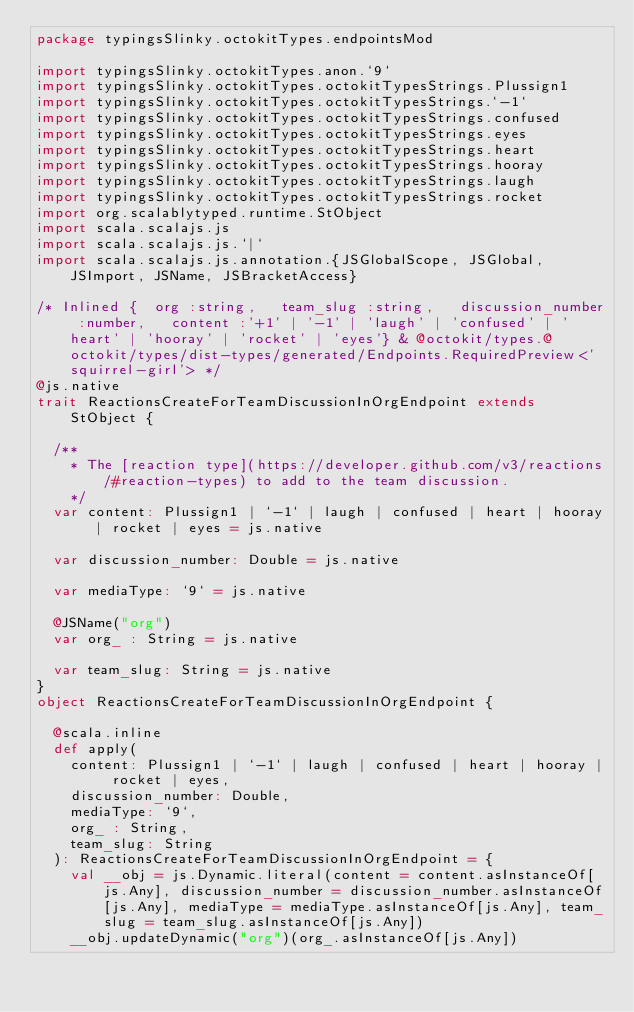Convert code to text. <code><loc_0><loc_0><loc_500><loc_500><_Scala_>package typingsSlinky.octokitTypes.endpointsMod

import typingsSlinky.octokitTypes.anon.`9`
import typingsSlinky.octokitTypes.octokitTypesStrings.Plussign1
import typingsSlinky.octokitTypes.octokitTypesStrings.`-1`
import typingsSlinky.octokitTypes.octokitTypesStrings.confused
import typingsSlinky.octokitTypes.octokitTypesStrings.eyes
import typingsSlinky.octokitTypes.octokitTypesStrings.heart
import typingsSlinky.octokitTypes.octokitTypesStrings.hooray
import typingsSlinky.octokitTypes.octokitTypesStrings.laugh
import typingsSlinky.octokitTypes.octokitTypesStrings.rocket
import org.scalablytyped.runtime.StObject
import scala.scalajs.js
import scala.scalajs.js.`|`
import scala.scalajs.js.annotation.{JSGlobalScope, JSGlobal, JSImport, JSName, JSBracketAccess}

/* Inlined {  org :string,   team_slug :string,   discussion_number :number,   content :'+1' | '-1' | 'laugh' | 'confused' | 'heart' | 'hooray' | 'rocket' | 'eyes'} & @octokit/types.@octokit/types/dist-types/generated/Endpoints.RequiredPreview<'squirrel-girl'> */
@js.native
trait ReactionsCreateForTeamDiscussionInOrgEndpoint extends StObject {
  
  /**
    * The [reaction type](https://developer.github.com/v3/reactions/#reaction-types) to add to the team discussion.
    */
  var content: Plussign1 | `-1` | laugh | confused | heart | hooray | rocket | eyes = js.native
  
  var discussion_number: Double = js.native
  
  var mediaType: `9` = js.native
  
  @JSName("org")
  var org_ : String = js.native
  
  var team_slug: String = js.native
}
object ReactionsCreateForTeamDiscussionInOrgEndpoint {
  
  @scala.inline
  def apply(
    content: Plussign1 | `-1` | laugh | confused | heart | hooray | rocket | eyes,
    discussion_number: Double,
    mediaType: `9`,
    org_ : String,
    team_slug: String
  ): ReactionsCreateForTeamDiscussionInOrgEndpoint = {
    val __obj = js.Dynamic.literal(content = content.asInstanceOf[js.Any], discussion_number = discussion_number.asInstanceOf[js.Any], mediaType = mediaType.asInstanceOf[js.Any], team_slug = team_slug.asInstanceOf[js.Any])
    __obj.updateDynamic("org")(org_.asInstanceOf[js.Any])</code> 